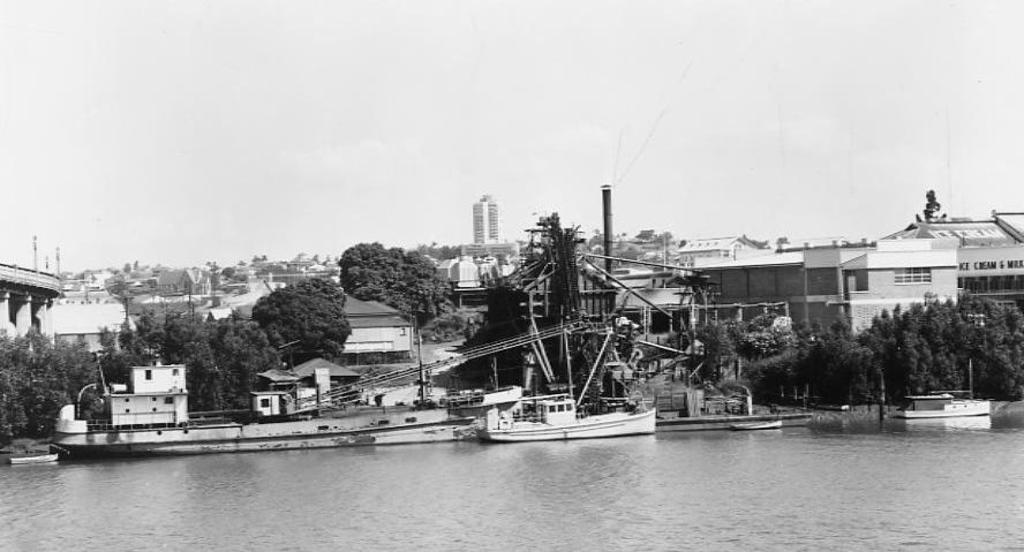What is the color scheme of the image? The image is black and white. What can be seen floating on the water in the image? There are boats in the water. What type of vegetation is present in the image? There are trees in the image. What type of structures can be seen in the image? There are buildings in the image. What is visible above the water and structures in the image? The sky is visible in the image. What type of underwear is hanging on the trees in the image? There is no underwear present in the image; it features boats, trees, buildings, and a sky. What can be seen being used to draw on the buildings in the image? There is no chalk or drawing activity present in the image; it is a scene with boats, trees, buildings, and a sky. 